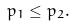Convert formula to latex. <formula><loc_0><loc_0><loc_500><loc_500>p _ { 1 } \leq p _ { 2 } .</formula> 